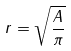<formula> <loc_0><loc_0><loc_500><loc_500>r = \sqrt { \frac { A } { \pi } }</formula> 